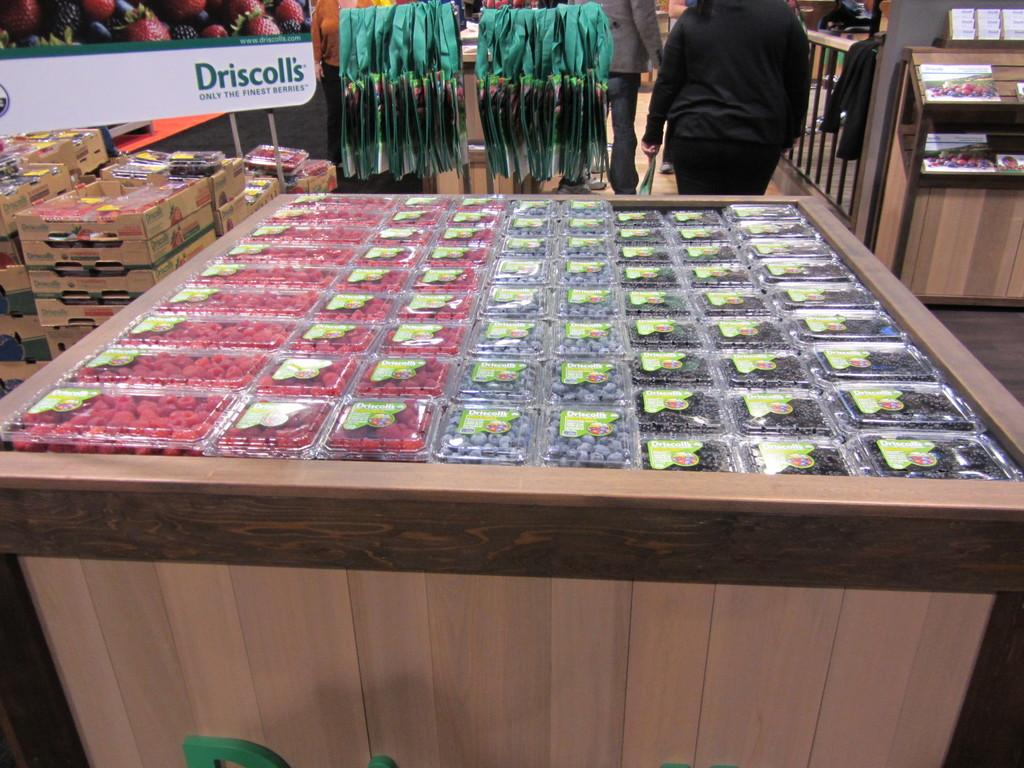<image>
Give a short and clear explanation of the subsequent image. Driscoll's raspberries, blueberries, and blackberries are displayed in this store. 